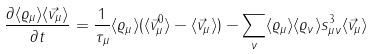<formula> <loc_0><loc_0><loc_500><loc_500>\frac { \partial \langle \varrho _ { \mu } \rangle \langle \vec { v } _ { \mu } \rangle } { \partial t } = \frac { 1 } { \tau _ { \mu } } \langle \varrho _ { \mu } \rangle ( \langle \vec { v } _ { \mu } ^ { 0 } \rangle - \langle \vec { v } _ { \mu } \rangle ) - \sum _ { \nu } \langle \varrho _ { \mu } \rangle \langle \varrho _ { \nu } \rangle s _ { \mu \nu } ^ { 3 } \langle \vec { v } _ { \mu } \rangle</formula> 